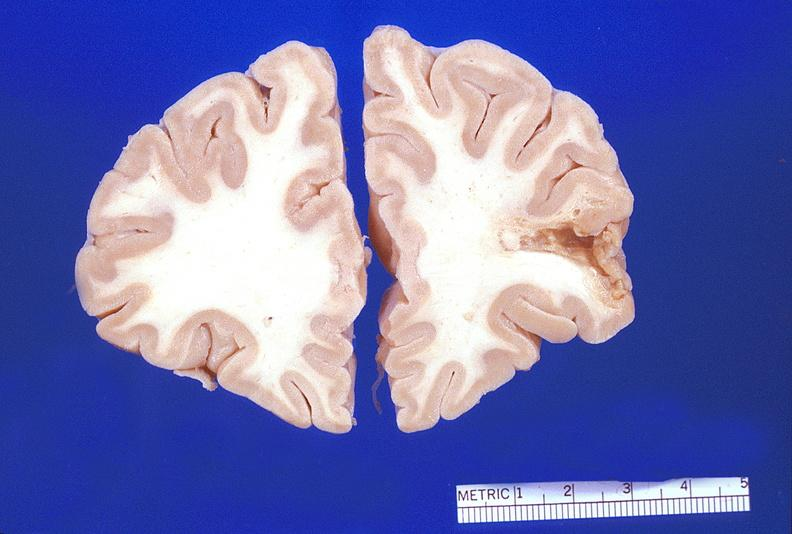s nervous present?
Answer the question using a single word or phrase. Yes 